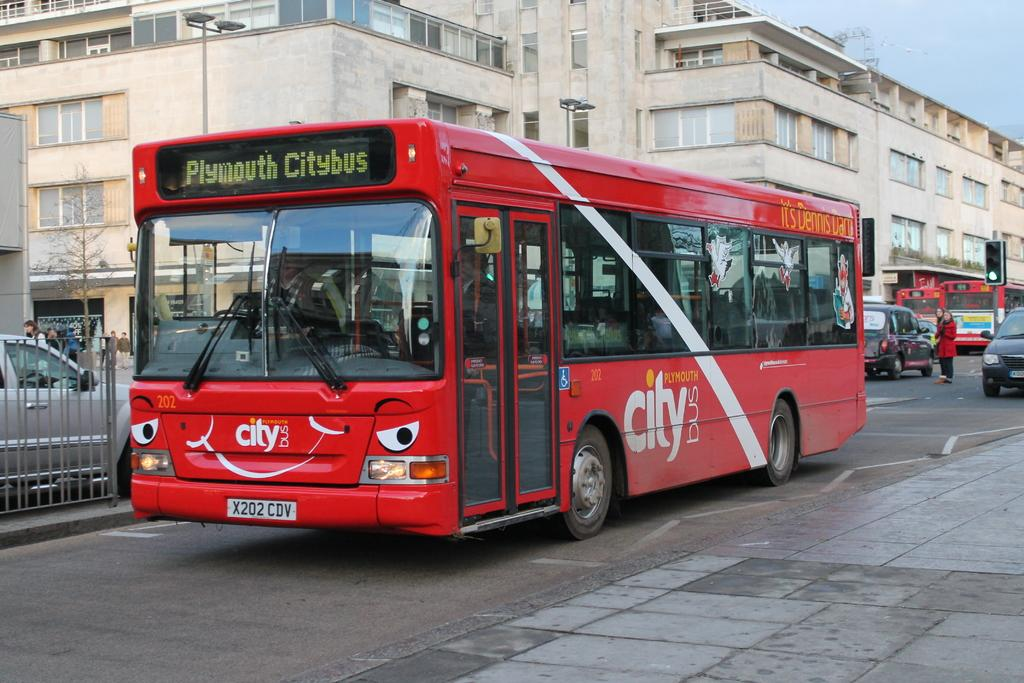<image>
Relay a brief, clear account of the picture shown. The Plymouth Citybus is red and has a face painted on the front. 